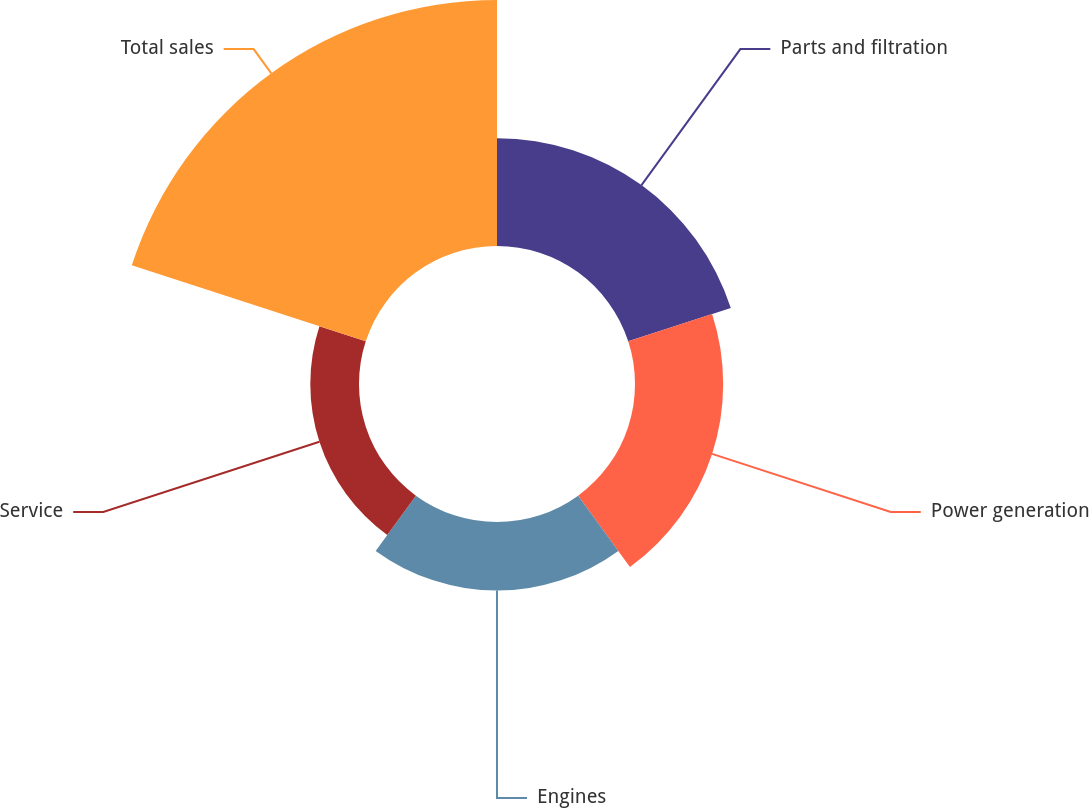Convert chart. <chart><loc_0><loc_0><loc_500><loc_500><pie_chart><fcel>Parts and filtration<fcel>Power generation<fcel>Engines<fcel>Service<fcel>Total sales<nl><fcel>19.29%<fcel>15.77%<fcel>12.24%<fcel>8.71%<fcel>44.0%<nl></chart> 